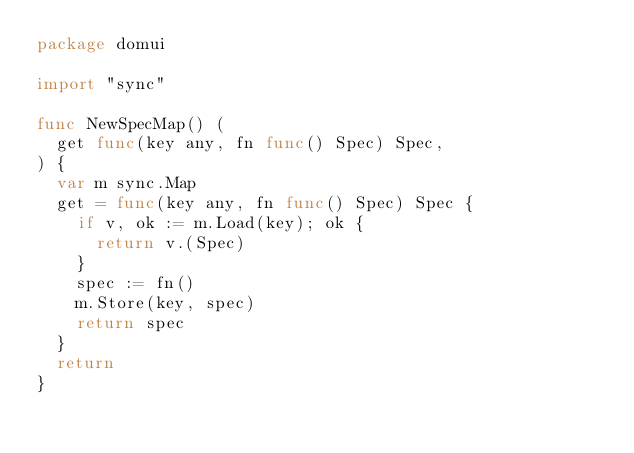Convert code to text. <code><loc_0><loc_0><loc_500><loc_500><_Go_>package domui

import "sync"

func NewSpecMap() (
	get func(key any, fn func() Spec) Spec,
) {
	var m sync.Map
	get = func(key any, fn func() Spec) Spec {
		if v, ok := m.Load(key); ok {
			return v.(Spec)
		}
		spec := fn()
		m.Store(key, spec)
		return spec
	}
	return
}
</code> 